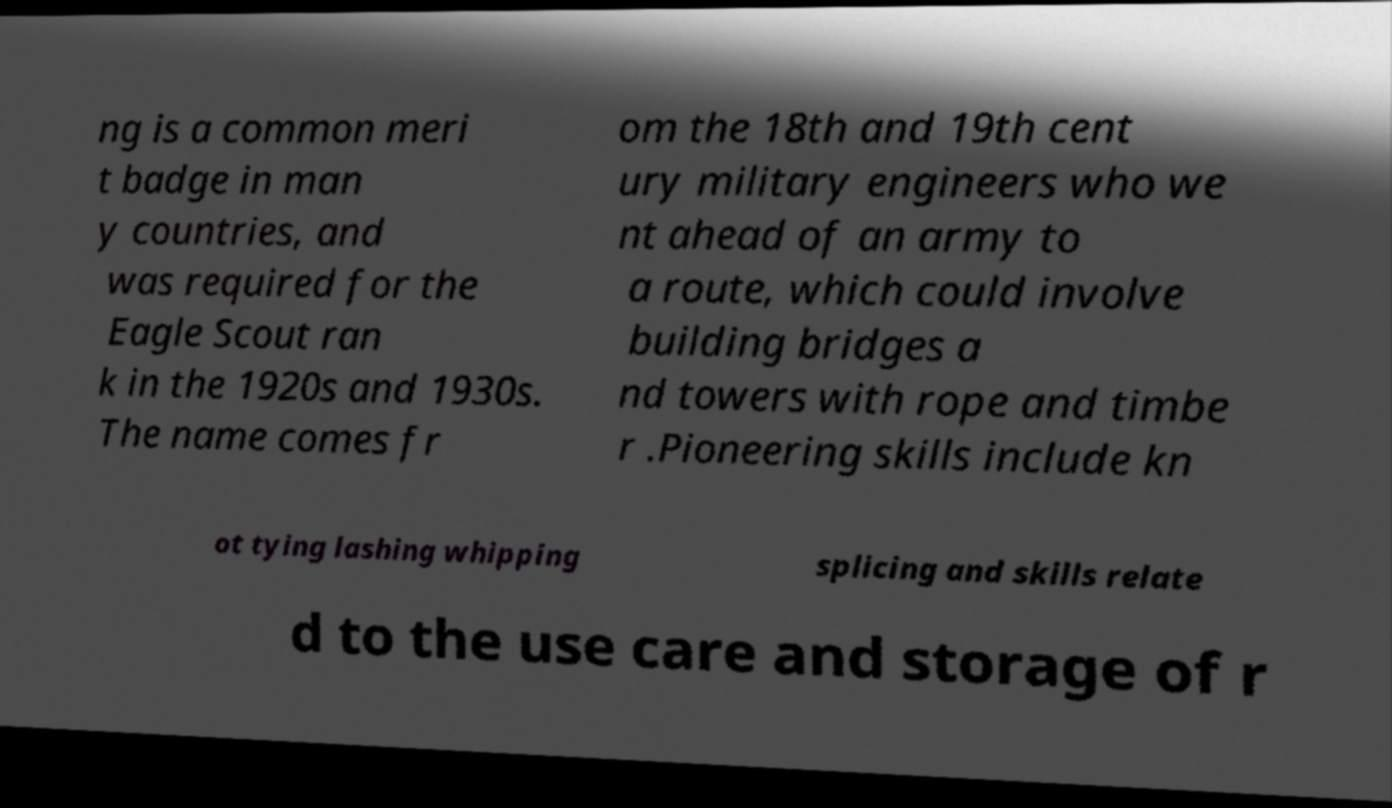For documentation purposes, I need the text within this image transcribed. Could you provide that? ng is a common meri t badge in man y countries, and was required for the Eagle Scout ran k in the 1920s and 1930s. The name comes fr om the 18th and 19th cent ury military engineers who we nt ahead of an army to a route, which could involve building bridges a nd towers with rope and timbe r .Pioneering skills include kn ot tying lashing whipping splicing and skills relate d to the use care and storage of r 